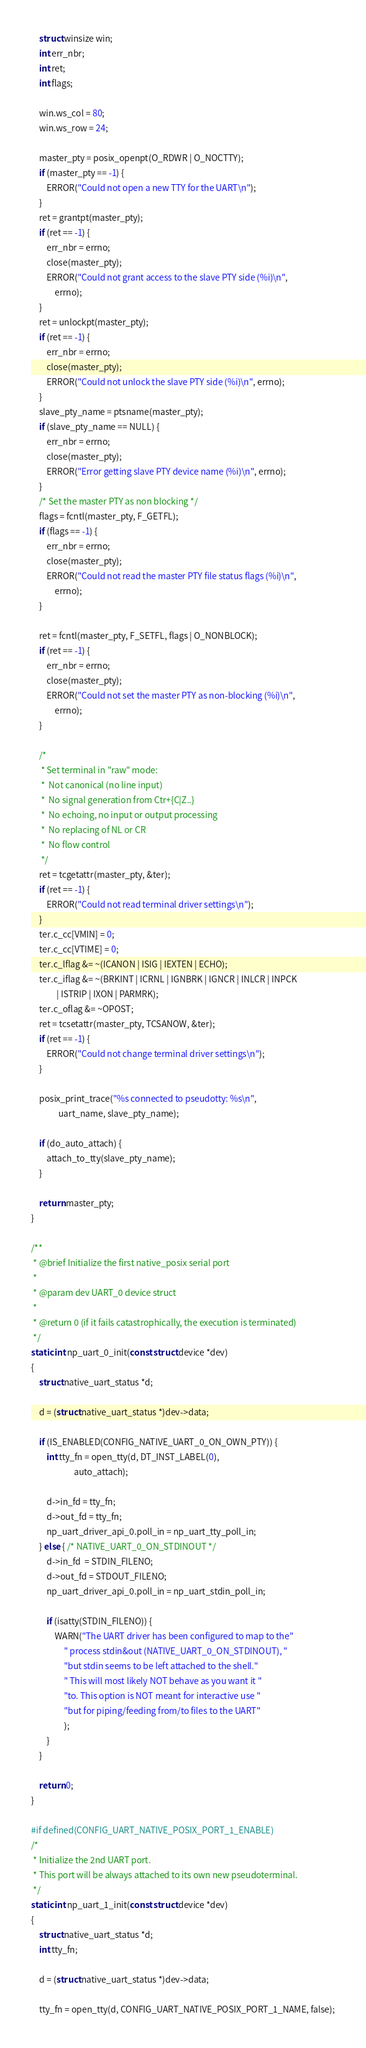<code> <loc_0><loc_0><loc_500><loc_500><_C_>	struct winsize win;
	int err_nbr;
	int ret;
	int flags;

	win.ws_col = 80;
	win.ws_row = 24;

	master_pty = posix_openpt(O_RDWR | O_NOCTTY);
	if (master_pty == -1) {
		ERROR("Could not open a new TTY for the UART\n");
	}
	ret = grantpt(master_pty);
	if (ret == -1) {
		err_nbr = errno;
		close(master_pty);
		ERROR("Could not grant access to the slave PTY side (%i)\n",
			errno);
	}
	ret = unlockpt(master_pty);
	if (ret == -1) {
		err_nbr = errno;
		close(master_pty);
		ERROR("Could not unlock the slave PTY side (%i)\n", errno);
	}
	slave_pty_name = ptsname(master_pty);
	if (slave_pty_name == NULL) {
		err_nbr = errno;
		close(master_pty);
		ERROR("Error getting slave PTY device name (%i)\n", errno);
	}
	/* Set the master PTY as non blocking */
	flags = fcntl(master_pty, F_GETFL);
	if (flags == -1) {
		err_nbr = errno;
		close(master_pty);
		ERROR("Could not read the master PTY file status flags (%i)\n",
			errno);
	}

	ret = fcntl(master_pty, F_SETFL, flags | O_NONBLOCK);
	if (ret == -1) {
		err_nbr = errno;
		close(master_pty);
		ERROR("Could not set the master PTY as non-blocking (%i)\n",
			errno);
	}

	/*
	 * Set terminal in "raw" mode:
	 *  Not canonical (no line input)
	 *  No signal generation from Ctr+{C|Z..}
	 *  No echoing, no input or output processing
	 *  No replacing of NL or CR
	 *  No flow control
	 */
	ret = tcgetattr(master_pty, &ter);
	if (ret == -1) {
		ERROR("Could not read terminal driver settings\n");
	}
	ter.c_cc[VMIN] = 0;
	ter.c_cc[VTIME] = 0;
	ter.c_lflag &= ~(ICANON | ISIG | IEXTEN | ECHO);
	ter.c_iflag &= ~(BRKINT | ICRNL | IGNBRK | IGNCR | INLCR | INPCK
			 | ISTRIP | IXON | PARMRK);
	ter.c_oflag &= ~OPOST;
	ret = tcsetattr(master_pty, TCSANOW, &ter);
	if (ret == -1) {
		ERROR("Could not change terminal driver settings\n");
	}

	posix_print_trace("%s connected to pseudotty: %s\n",
			  uart_name, slave_pty_name);

	if (do_auto_attach) {
		attach_to_tty(slave_pty_name);
	}

	return master_pty;
}

/**
 * @brief Initialize the first native_posix serial port
 *
 * @param dev UART_0 device struct
 *
 * @return 0 (if it fails catastrophically, the execution is terminated)
 */
static int np_uart_0_init(const struct device *dev)
{
	struct native_uart_status *d;

	d = (struct native_uart_status *)dev->data;

	if (IS_ENABLED(CONFIG_NATIVE_UART_0_ON_OWN_PTY)) {
		int tty_fn = open_tty(d, DT_INST_LABEL(0),
				      auto_attach);

		d->in_fd = tty_fn;
		d->out_fd = tty_fn;
		np_uart_driver_api_0.poll_in = np_uart_tty_poll_in;
	} else { /* NATIVE_UART_0_ON_STDINOUT */
		d->in_fd  = STDIN_FILENO;
		d->out_fd = STDOUT_FILENO;
		np_uart_driver_api_0.poll_in = np_uart_stdin_poll_in;

		if (isatty(STDIN_FILENO)) {
			WARN("The UART driver has been configured to map to the"
			     " process stdin&out (NATIVE_UART_0_ON_STDINOUT), "
			     "but stdin seems to be left attached to the shell."
			     " This will most likely NOT behave as you want it "
			     "to. This option is NOT meant for interactive use "
			     "but for piping/feeding from/to files to the UART"
			     );
		}
	}

	return 0;
}

#if defined(CONFIG_UART_NATIVE_POSIX_PORT_1_ENABLE)
/*
 * Initialize the 2nd UART port.
 * This port will be always attached to its own new pseudoterminal.
 */
static int np_uart_1_init(const struct device *dev)
{
	struct native_uart_status *d;
	int tty_fn;

	d = (struct native_uart_status *)dev->data;

	tty_fn = open_tty(d, CONFIG_UART_NATIVE_POSIX_PORT_1_NAME, false);
</code> 